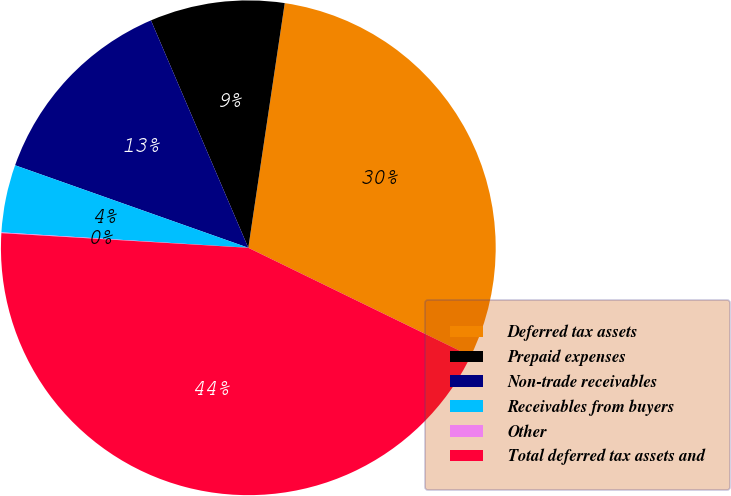<chart> <loc_0><loc_0><loc_500><loc_500><pie_chart><fcel>Deferred tax assets<fcel>Prepaid expenses<fcel>Non-trade receivables<fcel>Receivables from buyers<fcel>Other<fcel>Total deferred tax assets and<nl><fcel>29.86%<fcel>8.79%<fcel>13.15%<fcel>4.42%<fcel>0.05%<fcel>43.73%<nl></chart> 